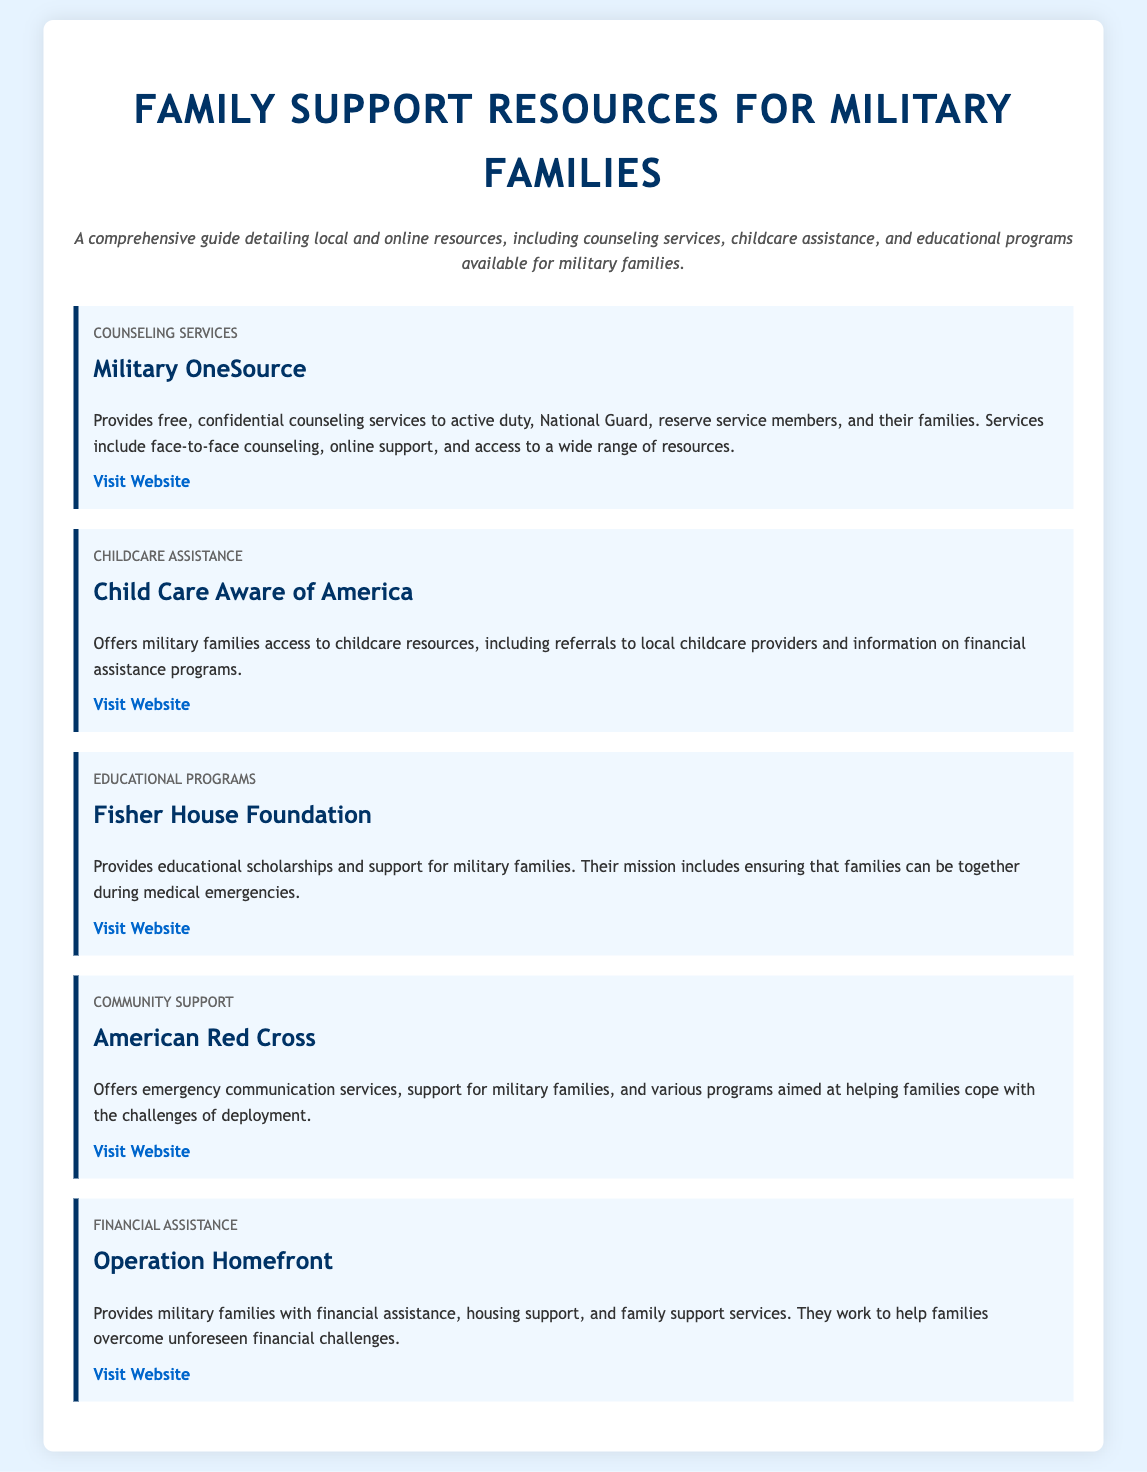What organization provides free, confidential counseling services? The document states that Military OneSource offers free, confidential counseling services to military families.
Answer: Military OneSource What is the focus of Child Care Aware of America? According to the document, Child Care Aware of America provides access to childcare resources for military families.
Answer: Childcare resources What kind of support does the Fisher House Foundation provide? The document mentions that the Fisher House Foundation provides educational scholarships and support for military families.
Answer: Educational scholarships Which organization offers emergency communication services to military families? The document specifies that the American Red Cross offers emergency communication services.
Answer: American Red Cross What type of assistance does Operation Homefront provide? Operation Homefront is described in the document as providing financial assistance and housing support to military families.
Answer: Financial assistance How many categories of resources are mentioned in the document? The document lists five categories of resources available for military families.
Answer: Five What is a common feature of all the organizations listed in the document? The document notes that all organizations provide support and resources specifically tailored for military families.
Answer: Support for military families Which service is designed for coping with the challenges of deployment? The American Red Cross, as mentioned in the document, offers services that help families cope with deployment challenges.
Answer: American Red Cross 